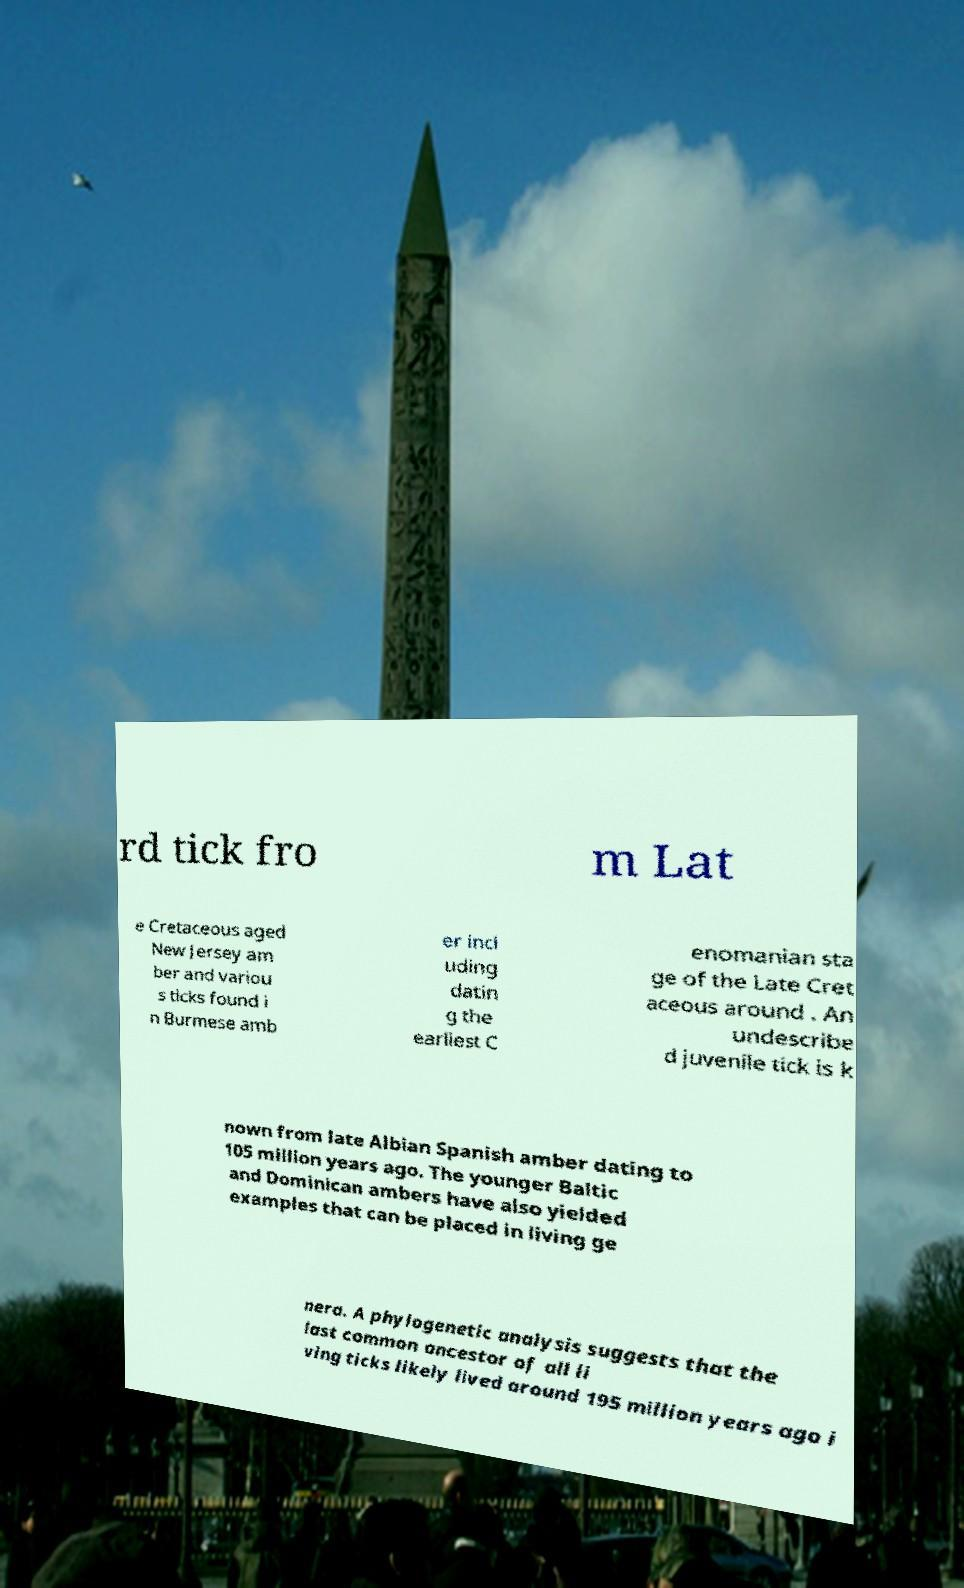There's text embedded in this image that I need extracted. Can you transcribe it verbatim? rd tick fro m Lat e Cretaceous aged New Jersey am ber and variou s ticks found i n Burmese amb er incl uding datin g the earliest C enomanian sta ge of the Late Cret aceous around . An undescribe d juvenile tick is k nown from late Albian Spanish amber dating to 105 million years ago. The younger Baltic and Dominican ambers have also yielded examples that can be placed in living ge nera. A phylogenetic analysis suggests that the last common ancestor of all li ving ticks likely lived around 195 million years ago i 